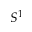Convert formula to latex. <formula><loc_0><loc_0><loc_500><loc_500>S ^ { 1 }</formula> 